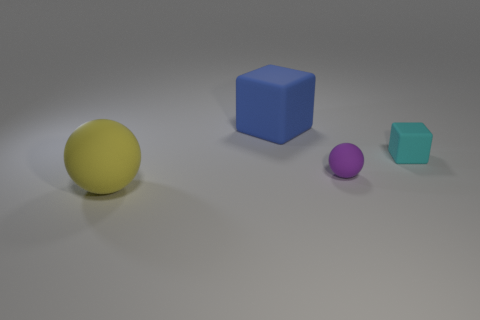What number of objects are either big green metal cubes or large blue rubber things?
Ensure brevity in your answer.  1. Is there a small rubber ball of the same color as the tiny cube?
Provide a short and direct response. No. There is a rubber cube that is in front of the blue block; how many small purple rubber objects are in front of it?
Offer a very short reply. 1. Are there more tiny purple things than large rubber objects?
Ensure brevity in your answer.  No. Are the large ball and the cyan thing made of the same material?
Your answer should be very brief. Yes. Is the number of tiny matte spheres that are in front of the purple rubber thing the same as the number of rubber blocks?
Offer a terse response. No. What number of other small cyan cubes are the same material as the small cyan block?
Provide a succinct answer. 0. Is the number of purple matte cylinders less than the number of big blue cubes?
Your answer should be very brief. Yes. What number of yellow matte objects are in front of the big rubber thing that is in front of the big rubber object behind the small cyan matte block?
Keep it short and to the point. 0. What number of big matte blocks are to the right of the blue object?
Your response must be concise. 0. 